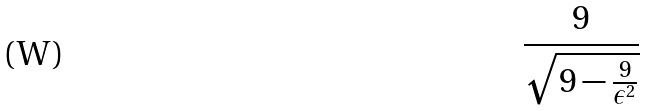Convert formula to latex. <formula><loc_0><loc_0><loc_500><loc_500>\frac { 9 } { \sqrt { 9 - \frac { 9 } { \epsilon ^ { 2 } } } }</formula> 